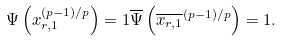<formula> <loc_0><loc_0><loc_500><loc_500>\Psi \left ( x _ { r , 1 } ^ { ( p - 1 ) / p } \right ) = 1 \overline { \Psi } \left ( \overline { x _ { r , 1 } } ^ { ( p - 1 ) / p } \right ) = 1 .</formula> 